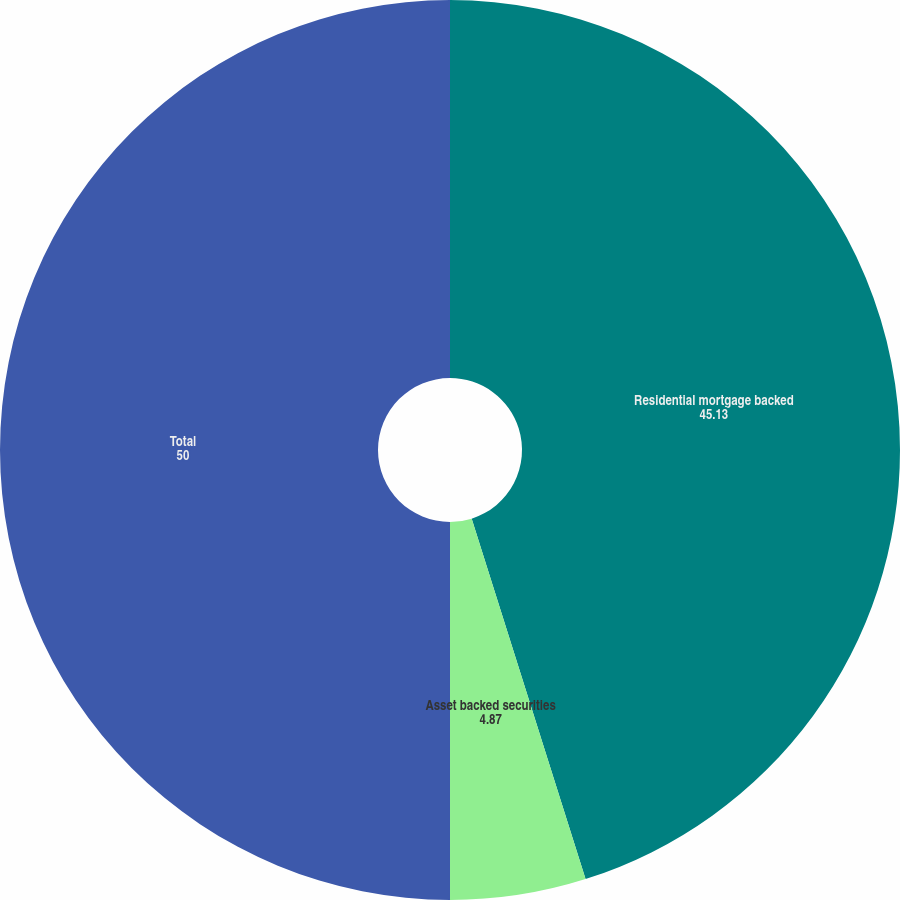Convert chart. <chart><loc_0><loc_0><loc_500><loc_500><pie_chart><fcel>Residential mortgage backed<fcel>Asset backed securities<fcel>Total<nl><fcel>45.13%<fcel>4.87%<fcel>50.0%<nl></chart> 